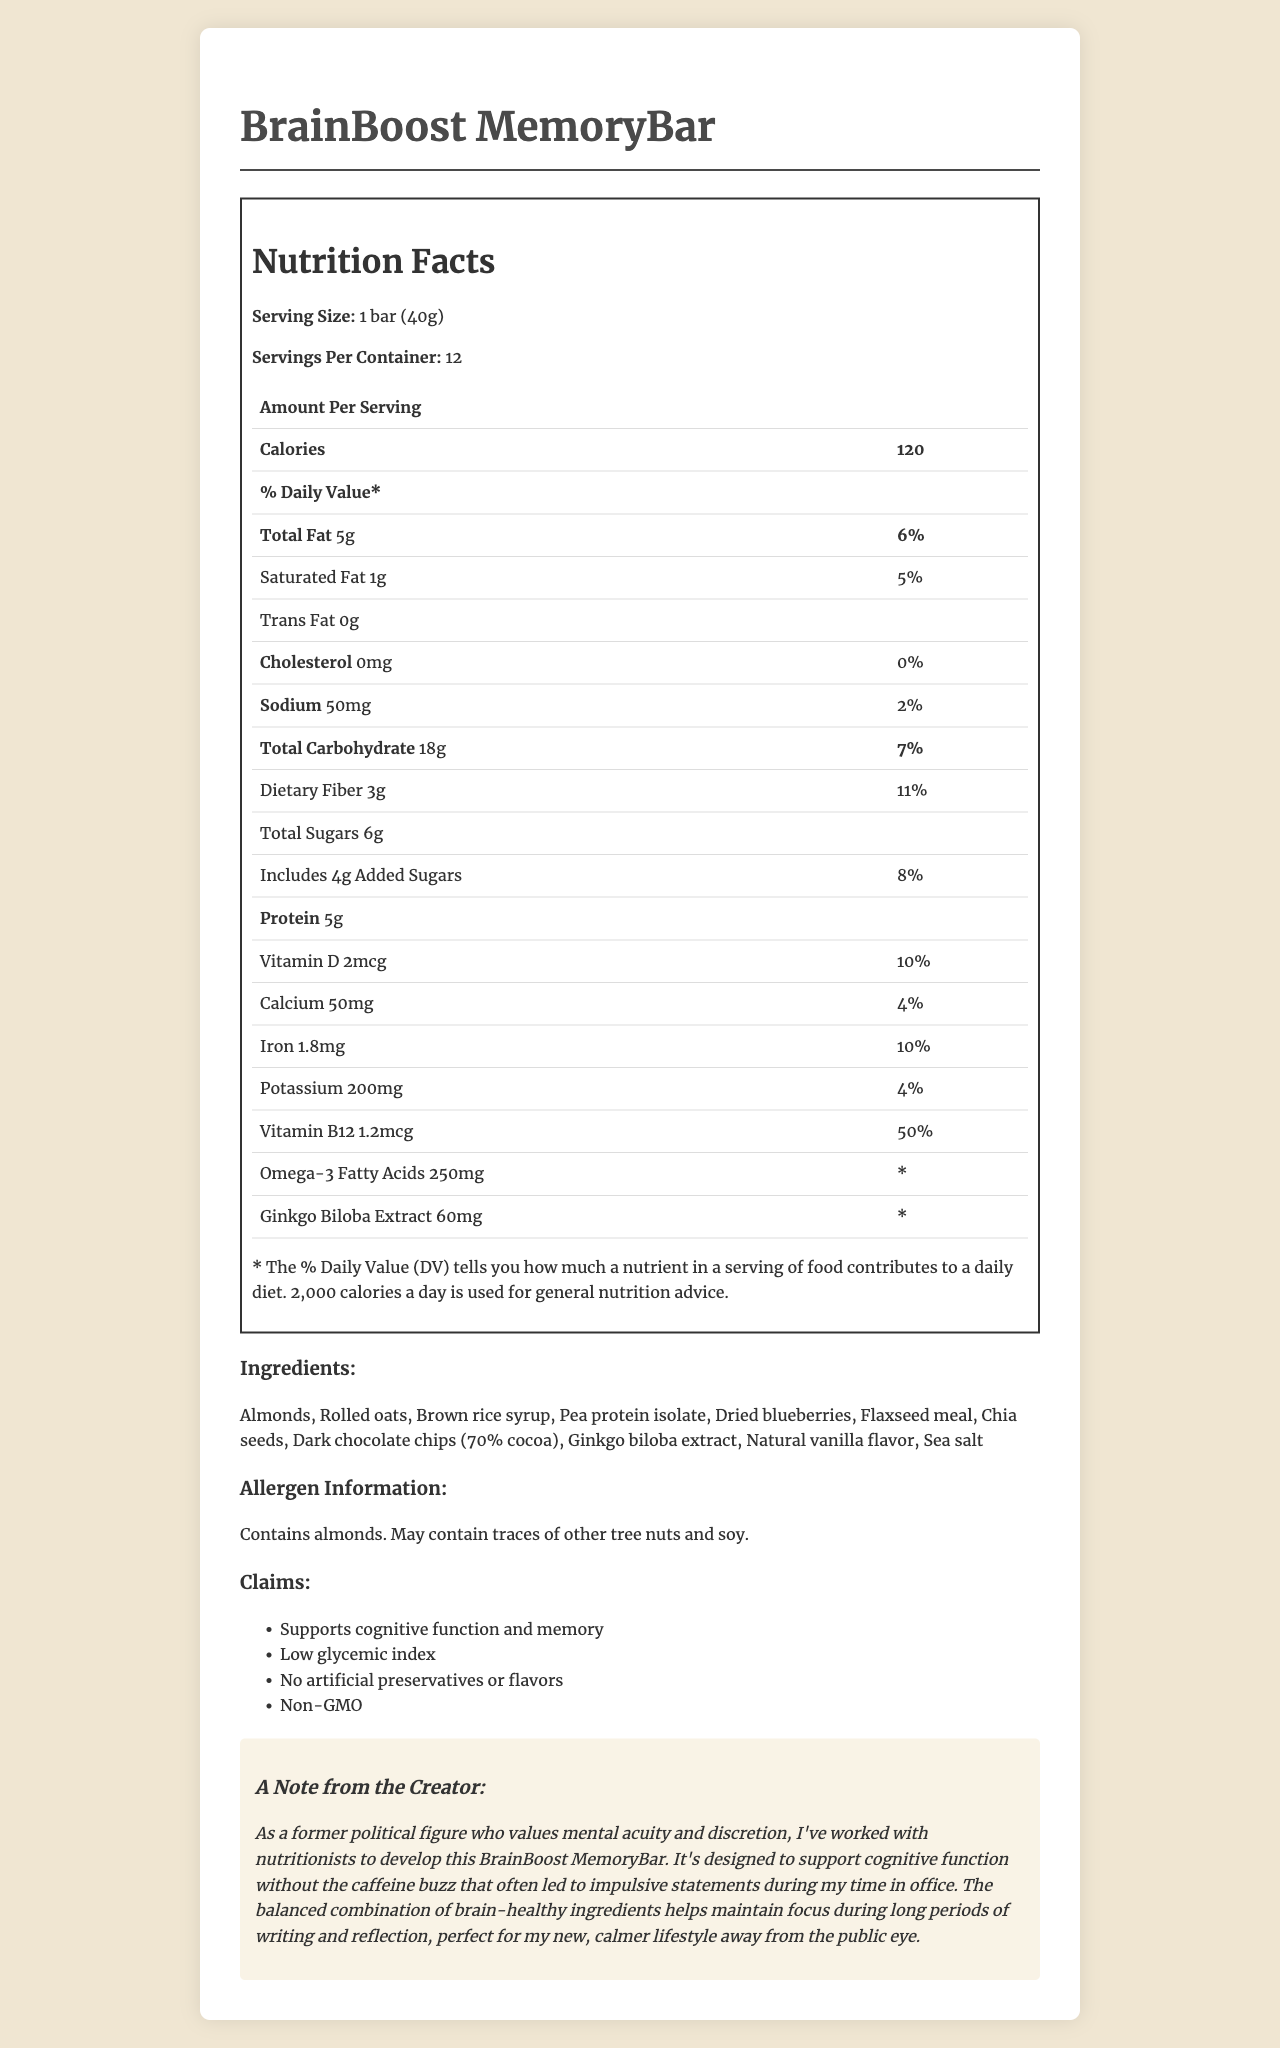what is the serving size? The serving size is explicitly listed as "1 bar (40g)" in the document.
Answer: 1 bar (40g) how many calories are there per serving? The document states that there are 120 calories per serving.
Answer: 120 what is the total fat content per serving? The total fat content per serving is mentioned as "Total Fat: 5g".
Answer: 5g how much protein does each serving contain? Each serving contains 5g of protein as listed in the nutrition facts.
Answer: 5g what ingredients are used in the BrainBoost MemoryBar? The ingredients are listed under the section titled "Ingredients".
Answer: Almonds, Rolled oats, Brown rice syrup, Pea protein isolate, Dried blueberries, Flaxseed meal, Chia seeds, Dark chocolate chips (70% cocoa), Ginkgo biloba extract, Natural vanilla flavor, Sea salt which of the following nutrients has the highest percent daily value? A. Vitamin D B. Vitamin B12 C. Iron D. Calcium Vitamin B12 has the highest percent daily value listed at 50%.
Answer: B. Vitamin B12 how many servings are there per container? A. 10 B. 12 C. 15 D. 20 The document states that there are 12 servings per container.
Answer: B. 12 is there any trans fat in this snack bar? The nutrition facts indicate that there is 0g of trans fat.
Answer: No does the snack bar contain any cholesterol? The document indicates 0mg of cholesterol per serving.
Answer: No summarize the main purpose of the product The product aims to support cognitive function and memory, has brain-healthy ingredients, and is crafted for people leading a calm, focused lifestyle without relying on caffeine.
Answer: The BrainBoost MemoryBar is a low-calorie snack designed to support cognitive function and memory. It contains brain-healthy ingredients and aims to maintain focus without caffeine, making it suitable for a calmer lifestyle. what is the total amount of sugar in one serving, including added sugars? The document lists 6g of total sugars and 4g of added sugars, but the total sugar content per serving is explicitly listed as 6g.
Answer: 6g what is the source of omega-3 fatty acids in the BrainBoost MemoryBar? The document does not specify which ingredient(s) provide the omega-3 fatty acids.
Answer: Not enough information what is the allergen information provided? The allergen information is listed as containing almonds and may contain traces of other tree nuts and soy.
Answer: Contains almonds. May contain traces of other tree nuts and soy. what are the claim statements made about the BrainBoost MemoryBar? The claim statements are listed under the section titled "Claims".
Answer: Supports cognitive function and memory, Low glycemic index, No artificial preservatives or flavors, Non-GMO does the BrainBoost MemoryBar contain any artificial preservatives or flavors? One of the claim statements specifies that there are no artificial preservatives or flavors in the product.
Answer: No what percent daily value of dietary fiber does the bar provide? The nutrition facts state that the bar provides 11% of the daily value of dietary fiber.
Answer: 11% 